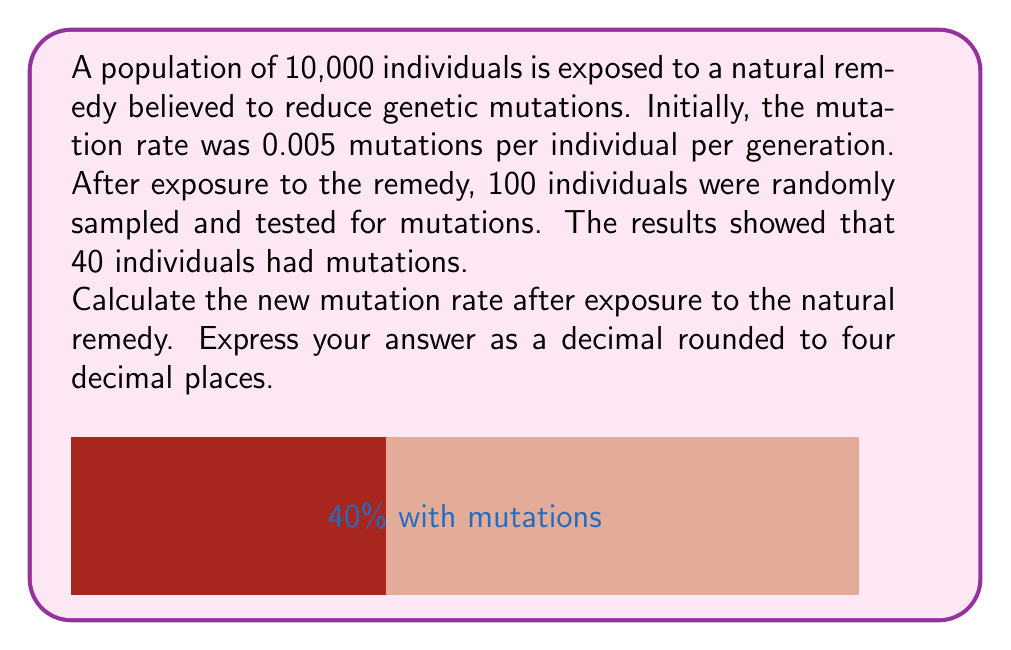Teach me how to tackle this problem. To calculate the new mutation rate, we'll follow these steps:

1) First, let's understand what the data represents:
   - Initial mutation rate: 0.005 mutations per individual per generation
   - Sample size: 100 individuals
   - Number of individuals with mutations in the sample: 40

2) The proportion of individuals with mutations in the sample is:
   $\frac{40}{100} = 0.4$ or 40%

3) This proportion can be considered as the new mutation rate for the population.

4) However, we need to consider the confidence interval for this estimate. The standard error (SE) for a proportion is given by:

   $SE = \sqrt{\frac{p(1-p)}{n}}$

   Where $p$ is the proportion and $n$ is the sample size.

5) Calculating the SE:
   $SE = \sqrt{\frac{0.4(1-0.4)}{100}} = \sqrt{\frac{0.24}{100}} = 0.0489$

6) For a 95% confidence interval, we use 1.96 as the z-score:
   
   $CI = p \pm 1.96 * SE$
   $CI = 0.4 \pm 1.96 * 0.0489$
   $CI = 0.4 \pm 0.0959$

7) This gives us a range of [0.3041, 0.4959] for the new mutation rate.

8) As a point estimate, we'll use the sample proportion of 0.4.

9) Rounding to four decimal places: 0.4000
Answer: 0.4000 